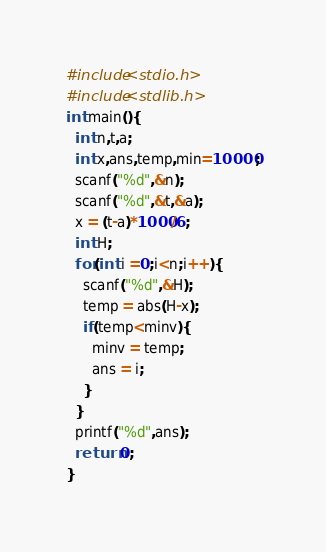<code> <loc_0><loc_0><loc_500><loc_500><_C_>#include<stdio.h>
#include<stdlib.h>
int main(){
  int n,t,a;
  int x,ans,temp,min=10000;
  scanf("%d",&n);
  scanf("%d",&t,&a);
  x = (t-a)*1000/6;
  int H;
  for(int i =0;i<n;i++){
    scanf("%d",&H);
    temp = abs(H-x);
    if(temp<minv){
      minv = temp;
      ans = i;
    }
  }
  printf("%d",ans);
  return 0;
}</code> 